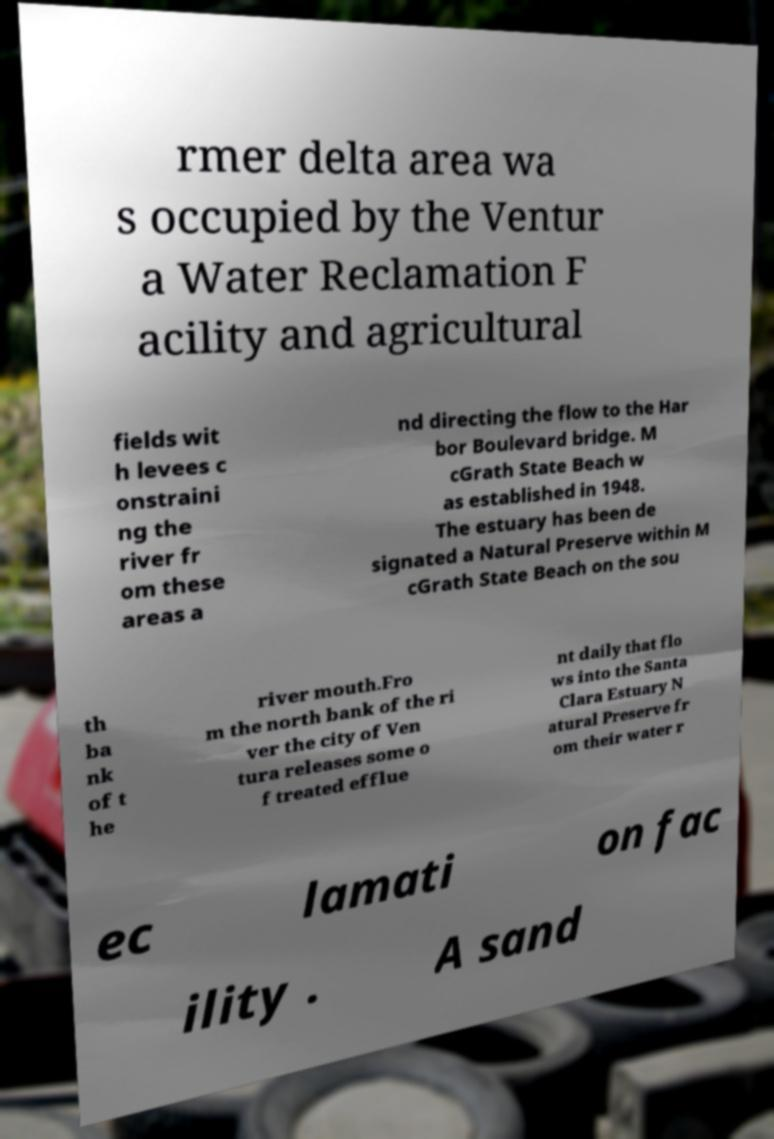Please read and relay the text visible in this image. What does it say? rmer delta area wa s occupied by the Ventur a Water Reclamation F acility and agricultural fields wit h levees c onstraini ng the river fr om these areas a nd directing the flow to the Har bor Boulevard bridge. M cGrath State Beach w as established in 1948. The estuary has been de signated a Natural Preserve within M cGrath State Beach on the sou th ba nk of t he river mouth.Fro m the north bank of the ri ver the city of Ven tura releases some o f treated efflue nt daily that flo ws into the Santa Clara Estuary N atural Preserve fr om their water r ec lamati on fac ility . A sand 